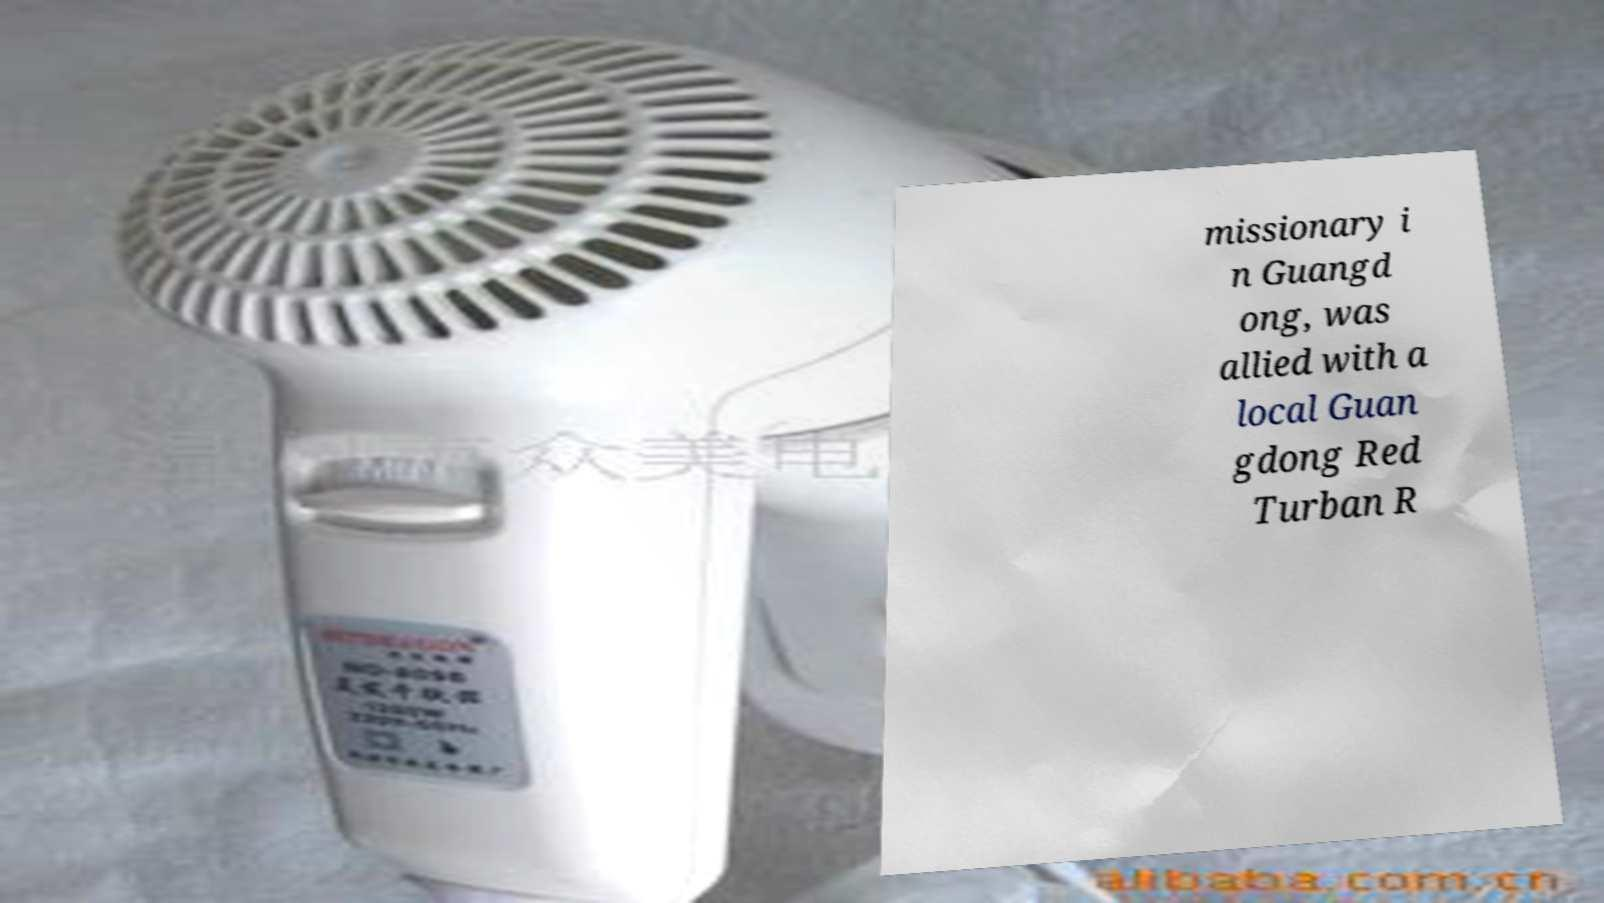Please identify and transcribe the text found in this image. missionary i n Guangd ong, was allied with a local Guan gdong Red Turban R 